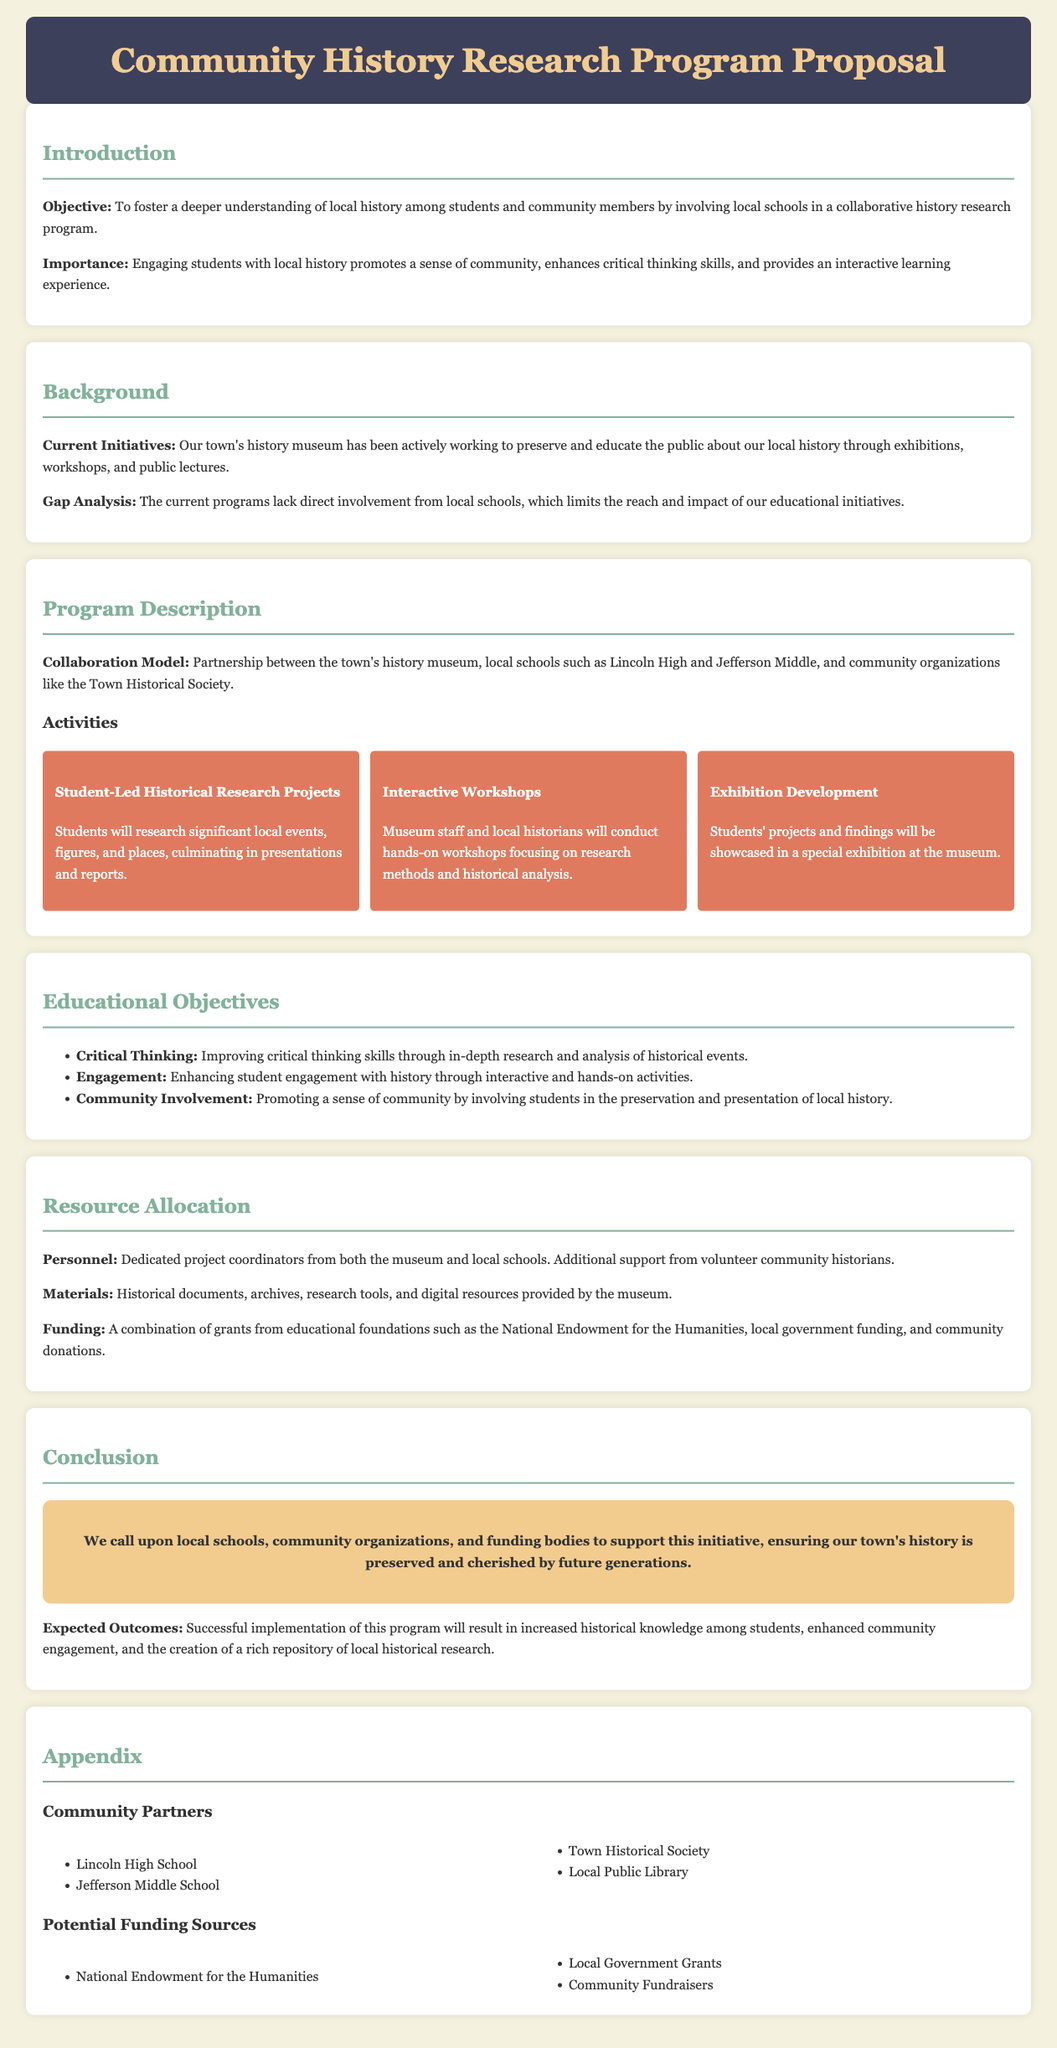What is the main objective of the program? The main objective of the program is to foster a deeper understanding of local history among students and community members.
Answer: To foster a deeper understanding of local history among students and community members Which schools are involved in the collaboration? The document lists specific schools that are part of the collaboration model, which includes Lincoln High and Jefferson Middle.
Answer: Lincoln High and Jefferson Middle What type of activities will be conducted in the program? The document outlines activities such as Student-Led Historical Research Projects, Interactive Workshops, and Exhibition Development.
Answer: Student-Led Historical Research Projects, Interactive Workshops, and Exhibition Development What is one educational objective of the program? The document specifies several educational objectives, including improving critical thinking skills through research and analysis.
Answer: Improving critical thinking skills Who will provide materials for the program? According to the resource allocation section, historical documents, archives, research tools, and digital resources will be provided by the museum.
Answer: The museum What is one potential funding source mentioned? The document mentions several potential funding sources, including the National Endowment for the Humanities.
Answer: National Endowment for the Humanities What is the purpose of involving students in the program? The document states that involving students promotes a sense of community by engaging them in the preservation and presentation of local history.
Answer: Promoting a sense of community What is one expected outcome of the program? The expected outcomes mentioned in the document include increased historical knowledge among students.
Answer: Increased historical knowledge among students 